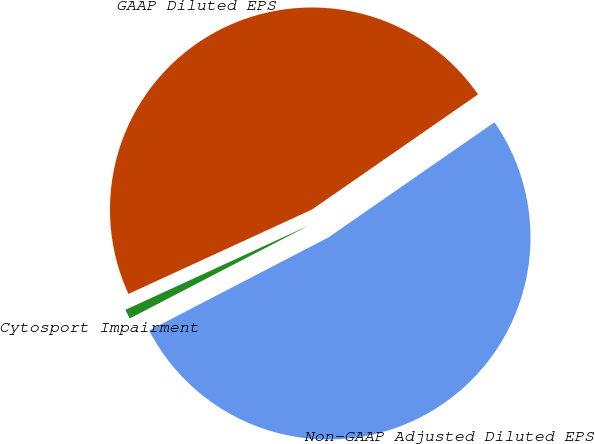Convert chart to OTSL. <chart><loc_0><loc_0><loc_500><loc_500><pie_chart><fcel>Non-GAAP Adjusted Diluted EPS<fcel>Cytosport Impairment<fcel>GAAP Diluted EPS<nl><fcel>52.03%<fcel>0.76%<fcel>47.21%<nl></chart> 